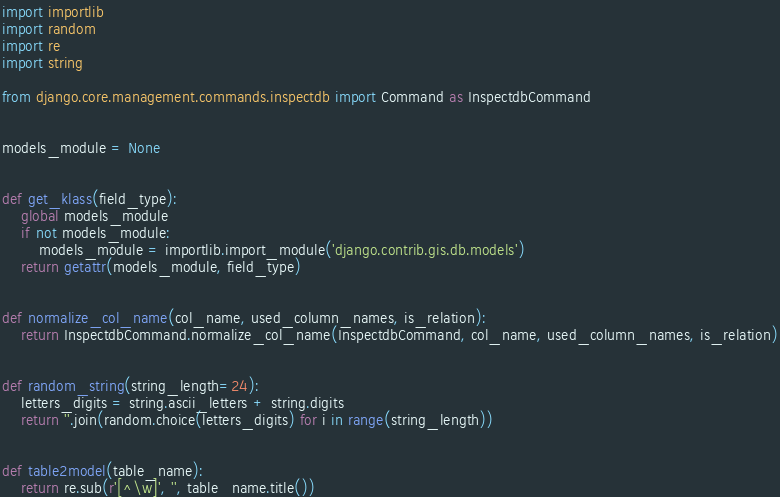Convert code to text. <code><loc_0><loc_0><loc_500><loc_500><_Python_>import importlib
import random
import re
import string

from django.core.management.commands.inspectdb import Command as InspectdbCommand


models_module = None


def get_klass(field_type):
    global models_module
    if not models_module:
        models_module = importlib.import_module('django.contrib.gis.db.models')
    return getattr(models_module, field_type)


def normalize_col_name(col_name, used_column_names, is_relation):
    return InspectdbCommand.normalize_col_name(InspectdbCommand, col_name, used_column_names, is_relation)


def random_string(string_length=24):
    letters_digits = string.ascii_letters + string.digits
    return ''.join(random.choice(letters_digits) for i in range(string_length))


def table2model(table_name):
    return re.sub(r'[^\w]', '', table_name.title())
</code> 